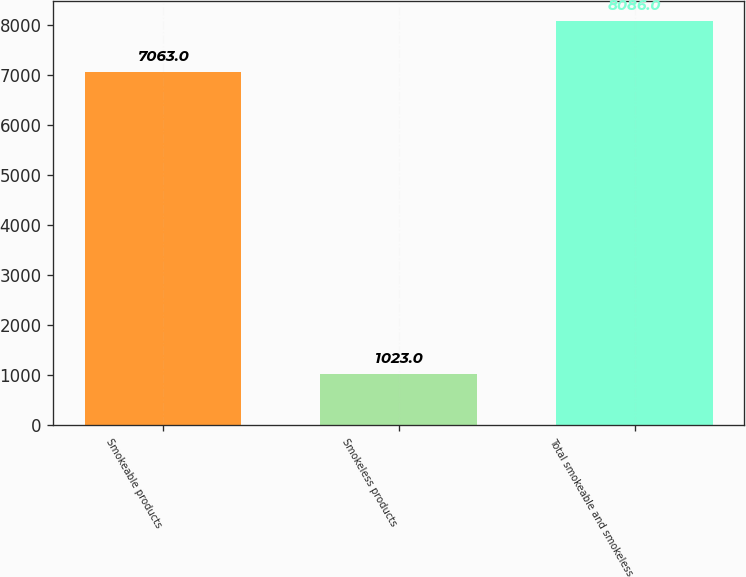<chart> <loc_0><loc_0><loc_500><loc_500><bar_chart><fcel>Smokeable products<fcel>Smokeless products<fcel>Total smokeable and smokeless<nl><fcel>7063<fcel>1023<fcel>8086<nl></chart> 